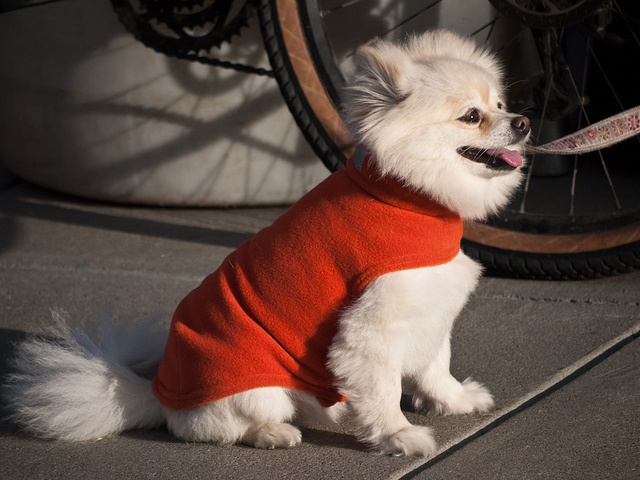Describe the objects in this image and their specific colors. I can see dog in black, maroon, lightgray, gray, and brown tones and bicycle in black, gray, and maroon tones in this image. 